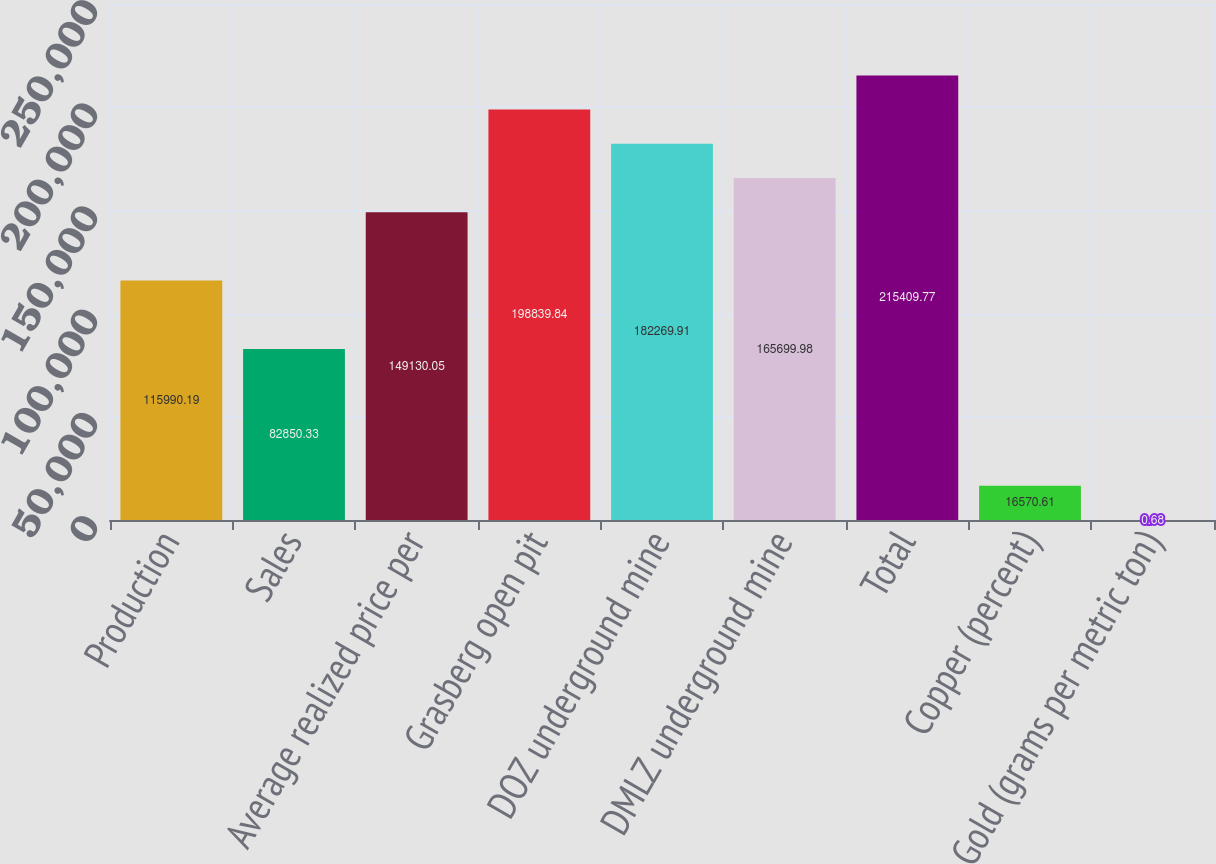Convert chart to OTSL. <chart><loc_0><loc_0><loc_500><loc_500><bar_chart><fcel>Production<fcel>Sales<fcel>Average realized price per<fcel>Grasberg open pit<fcel>DOZ underground mine<fcel>DMLZ underground mine<fcel>Total<fcel>Copper (percent)<fcel>Gold (grams per metric ton)<nl><fcel>115990<fcel>82850.3<fcel>149130<fcel>198840<fcel>182270<fcel>165700<fcel>215410<fcel>16570.6<fcel>0.68<nl></chart> 